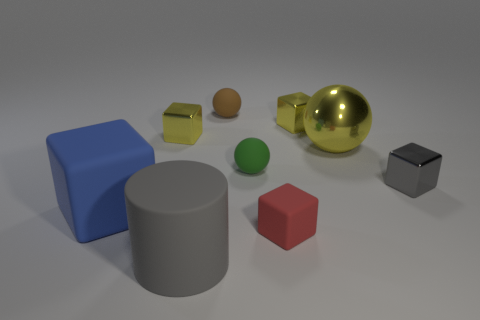Subtract all gray metallic cubes. How many cubes are left? 4 Subtract all red blocks. How many blocks are left? 4 Subtract all red cubes. Subtract all purple spheres. How many cubes are left? 4 Add 1 small blue metal cylinders. How many objects exist? 10 Subtract all spheres. How many objects are left? 6 Add 1 blue things. How many blue things are left? 2 Add 7 small red things. How many small red things exist? 8 Subtract 0 purple cubes. How many objects are left? 9 Subtract all gray cubes. Subtract all blue things. How many objects are left? 7 